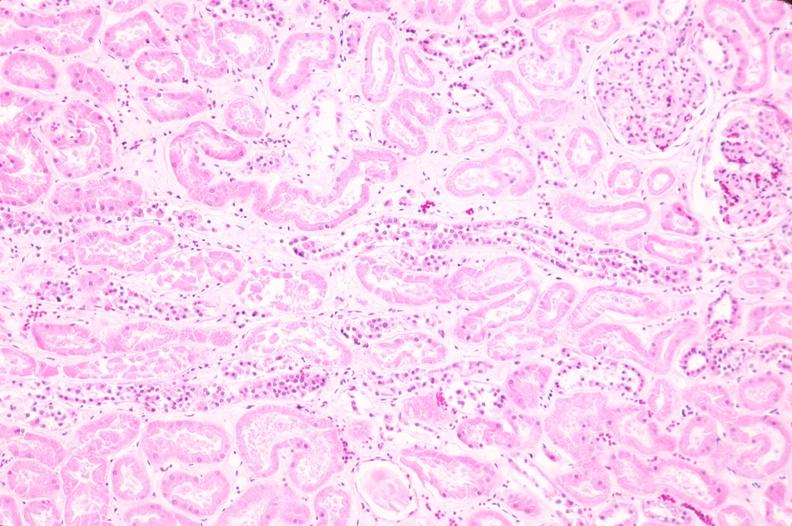what does this image show?
Answer the question using a single word or phrase. Kidney 